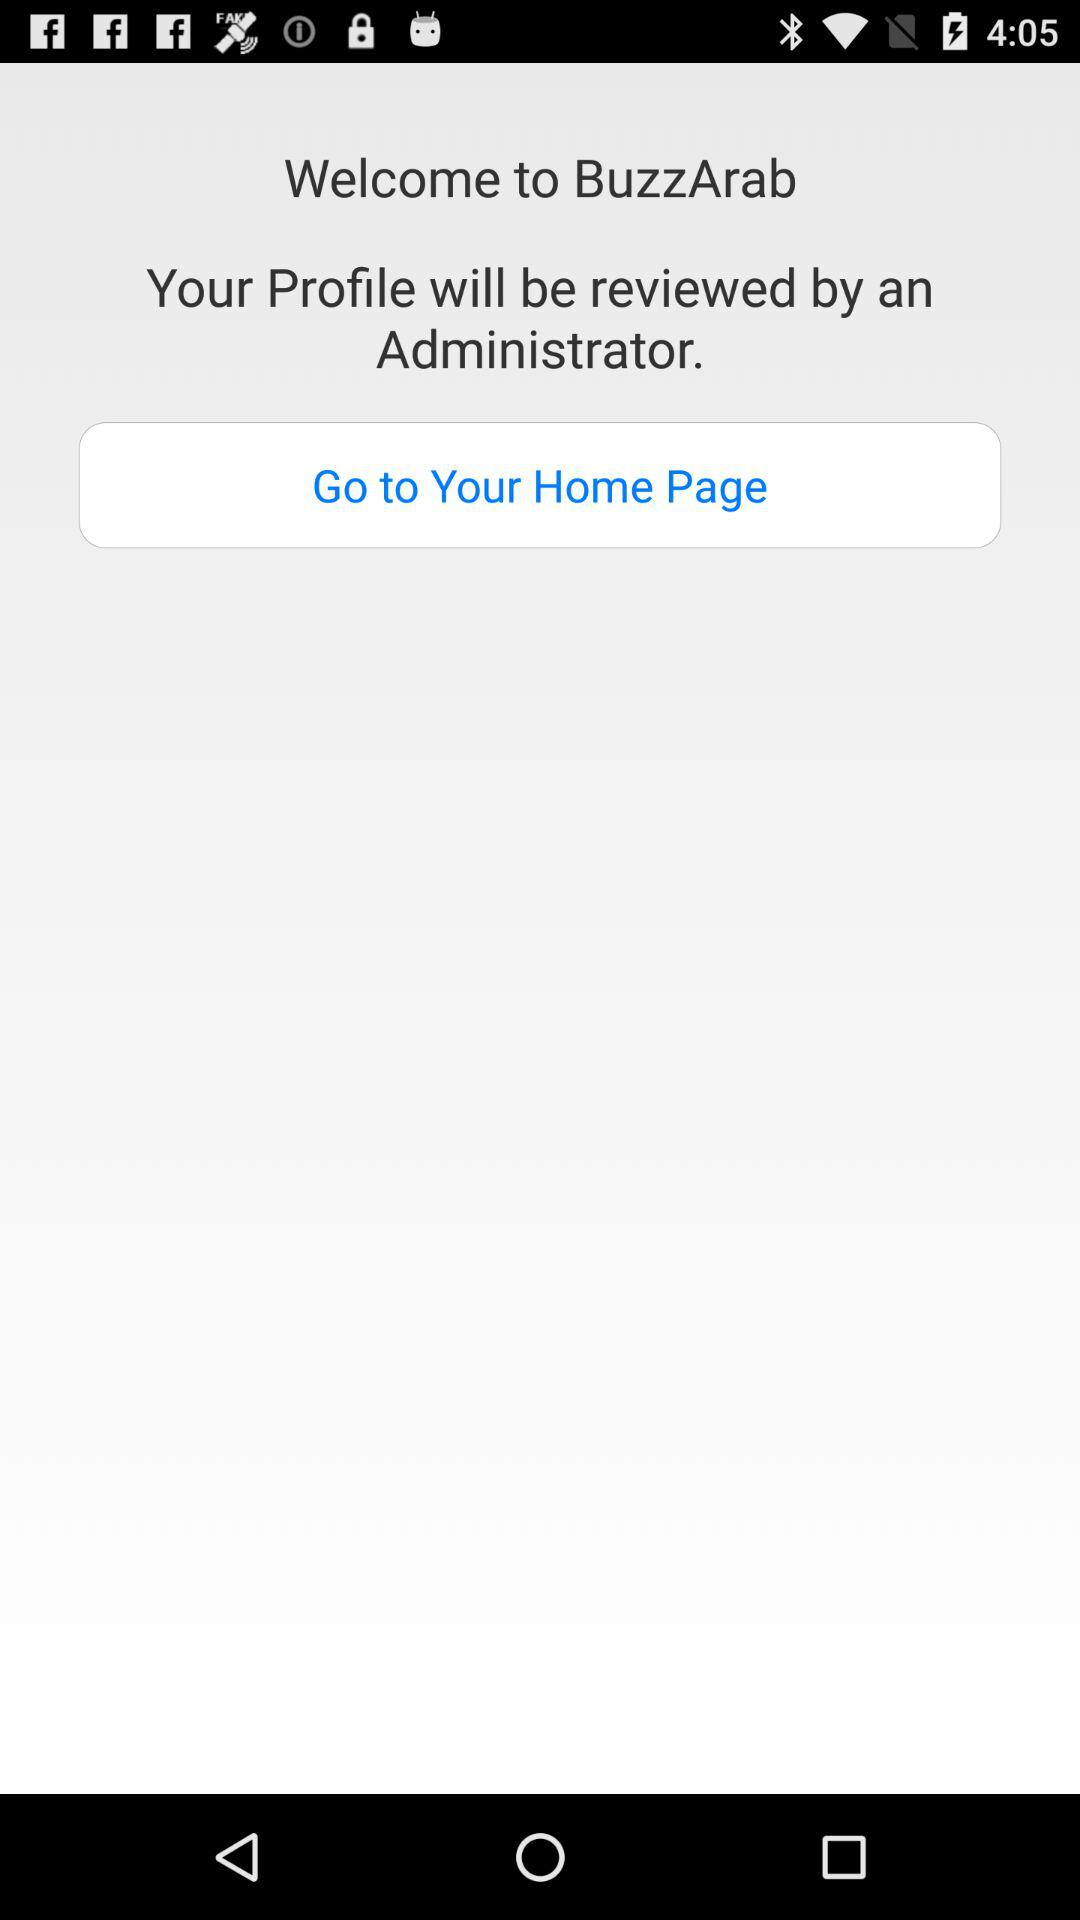How many people are online now?
When the provided information is insufficient, respond with <no answer>. <no answer> 